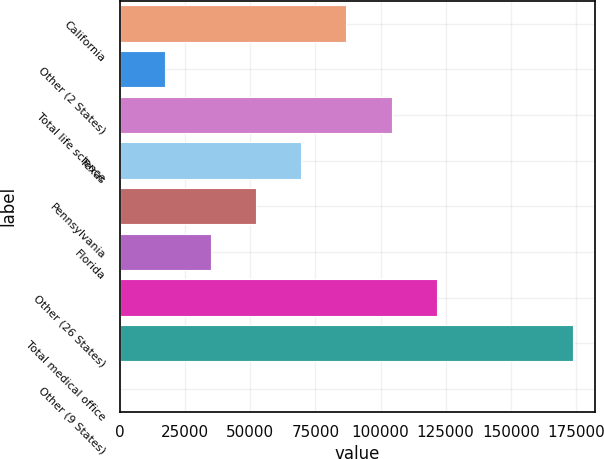Convert chart to OTSL. <chart><loc_0><loc_0><loc_500><loc_500><bar_chart><fcel>California<fcel>Other (2 States)<fcel>Total life science<fcel>Texas<fcel>Pennsylvania<fcel>Florida<fcel>Other (26 States)<fcel>Total medical office<fcel>Other (9 States)<nl><fcel>86867<fcel>17411<fcel>104231<fcel>69503<fcel>52139<fcel>34775<fcel>121595<fcel>173687<fcel>47<nl></chart> 